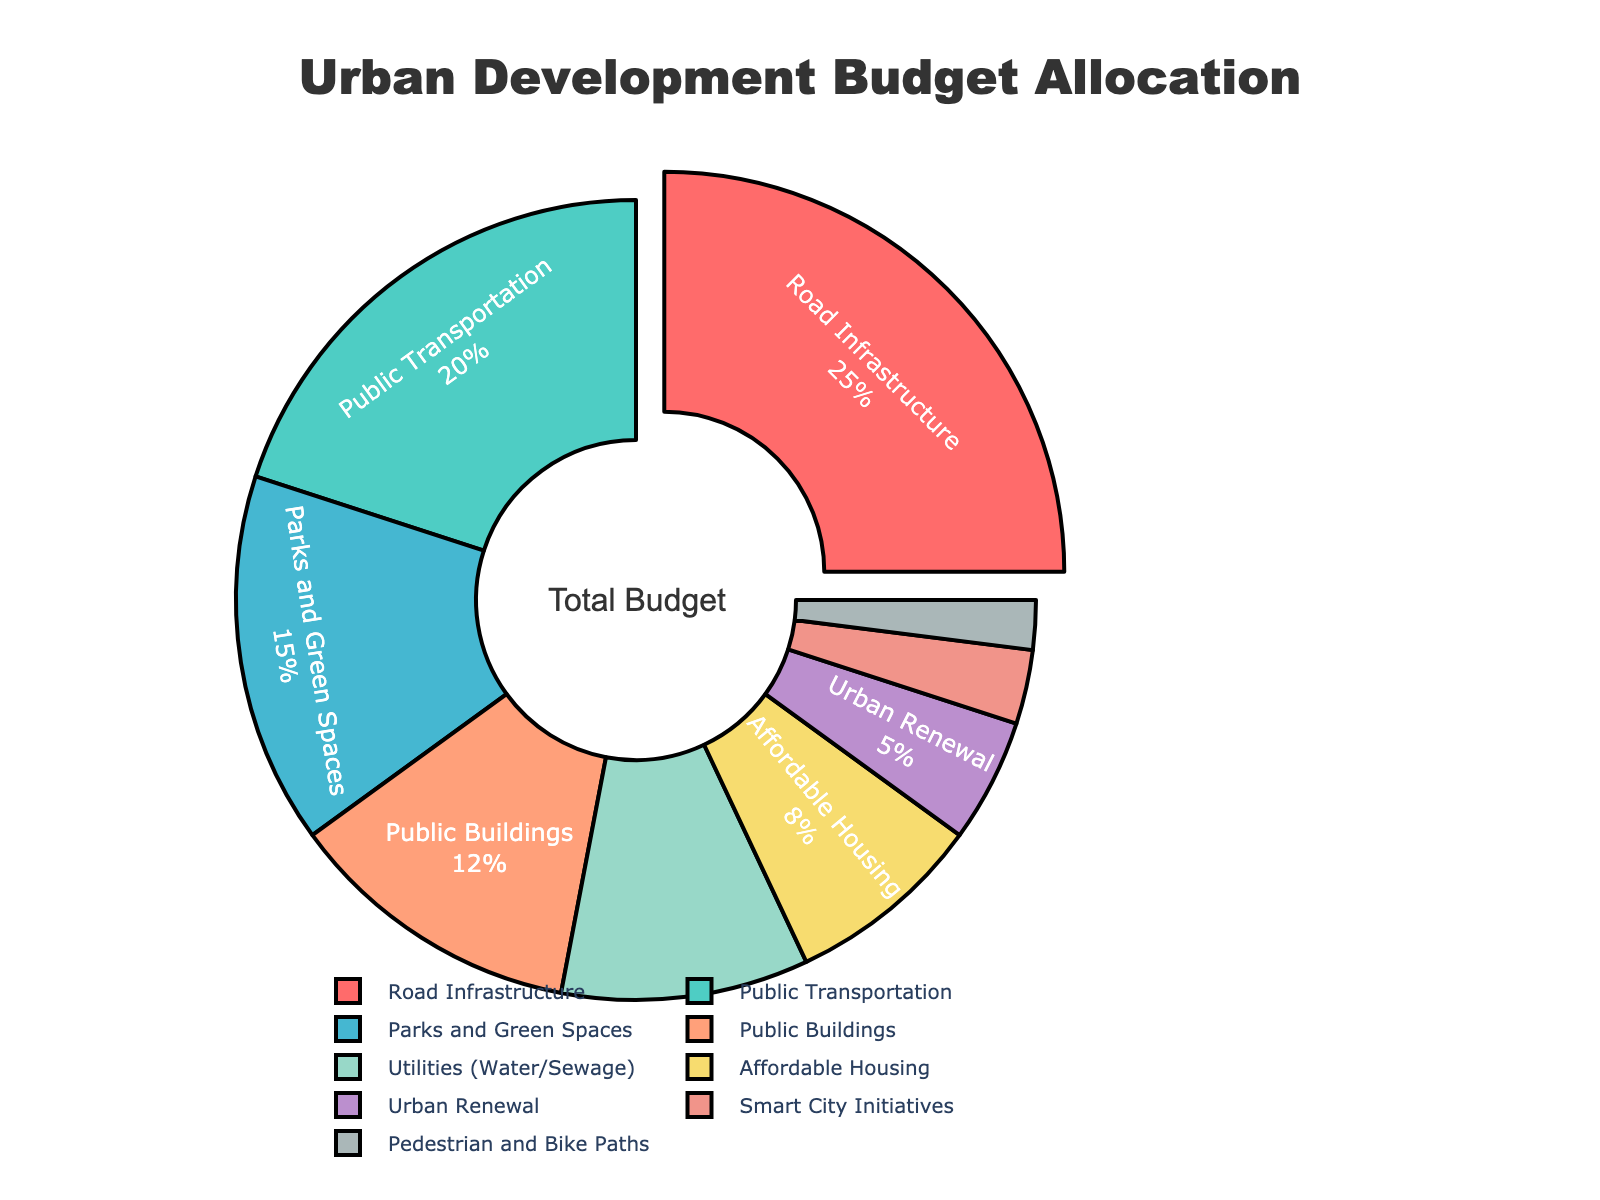Which category has the highest allocation percentage? The largest slice of the pie chart represents the category with the highest allocation. From the data, we see that "Road Infrastructure" has the highest allocation at 25%.
Answer: Road Infrastructure How much more is allocated to Public Transportation compared to Affordable Housing? The percentage for Public Transportation is 20%, and for Affordable Housing, it's 8%. The difference is 20% - 8% = 12%.
Answer: 12% What is the combined allocation for "Parks and Green Spaces" and "Public Buildings"? The percentages are 15% for Parks and Green Spaces and 12% for Public Buildings. Summing these gives 15% + 12% = 27%.
Answer: 27% Which categories have a lower allocation than Utilities (Water/Sewage)? Utilities have a 10% allocation. The categories with less than this are Affordable Housing (8%), Urban Renewal (5%), Smart City Initiatives (3%), and Pedestrian and Bike Paths (2%).
Answer: Affordable Housing, Urban Renewal, Smart City Initiatives, Pedestrian and Bike Paths What percentage of the budget is allocated to categories with more than 15% allocation? Only the "Road Infrastructure" category has more than 15% allocation, which is 25%.
Answer: 25% If the "Road Infrastructure" budget was reduced by 5%, how would the new allocation compare to Public Transportation? Reducing the "Road Infrastructure" budget by 5% from 25% gives 20%, which is equal to the Public Transportation budget of 20%.
Answer: Equal Compare the visual sizes and name two smallest allocated categories and their percentages. By examining the smallest slices in the pie chart, we see that "Pedestrian and Bike Paths" (2%) and "Smart City Initiatives" (3%) are the smallest slices.
Answer: Pedestrian and Bike Paths (2%), Smart City Initiatives (3%) How much more is allocated to Parks and Green Spaces compared to Urban Renewal? The percentage for Parks and Green Spaces is 15%, and for Urban Renewal, it is 5%. The difference is 15% - 5% = 10%.
Answer: 10% Which categories combined make up exactly half of the budget allocation? Summing the top percentages: Road Infrastructure (25%) + Public Transportation (20%) + Parks and Green Spaces (15%) totals to 60%, which is more than half. Therefore, we observe that combining Road Infrastructure (25%) and Public Transportation (20%) gives us 45%. Adding Utilities (10%) brings us to 50%. Thus, these three categories combined make exactly half.
Answer: Road Infrastructure, Public Transportation, Utilities 